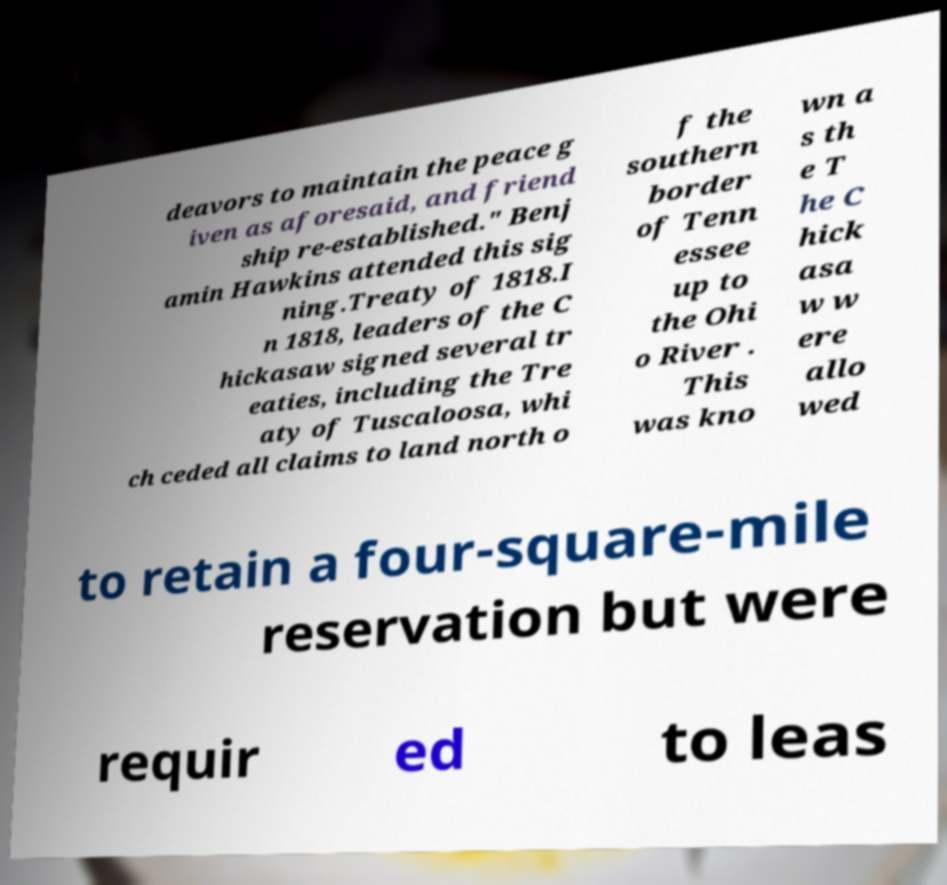For documentation purposes, I need the text within this image transcribed. Could you provide that? deavors to maintain the peace g iven as aforesaid, and friend ship re-established." Benj amin Hawkins attended this sig ning.Treaty of 1818.I n 1818, leaders of the C hickasaw signed several tr eaties, including the Tre aty of Tuscaloosa, whi ch ceded all claims to land north o f the southern border of Tenn essee up to the Ohi o River . This was kno wn a s th e T he C hick asa w w ere allo wed to retain a four-square-mile reservation but were requir ed to leas 